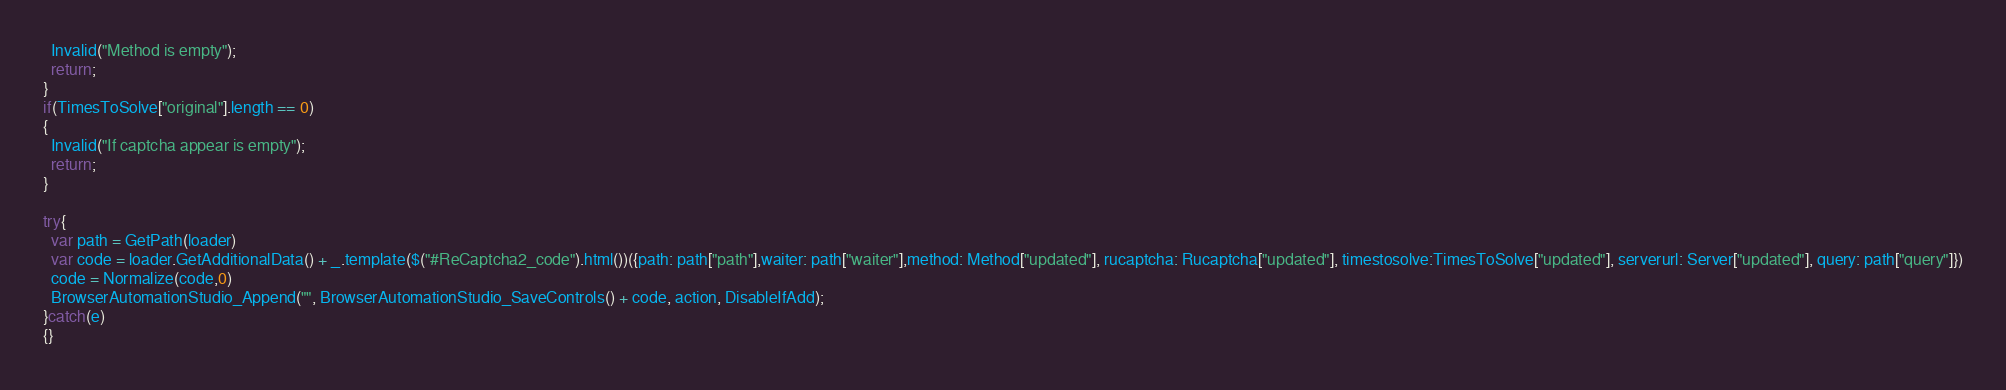<code> <loc_0><loc_0><loc_500><loc_500><_JavaScript_>  Invalid("Method is empty");
  return;
}
if(TimesToSolve["original"].length == 0)
{
  Invalid("If captcha appear is empty");
  return;
}

try{
  var path = GetPath(loader)
  var code = loader.GetAdditionalData() + _.template($("#ReCaptcha2_code").html())({path: path["path"],waiter: path["waiter"],method: Method["updated"], rucaptcha: Rucaptcha["updated"], timestosolve:TimesToSolve["updated"], serverurl: Server["updated"], query: path["query"]})
  code = Normalize(code,0)
  BrowserAutomationStudio_Append("", BrowserAutomationStudio_SaveControls() + code, action, DisableIfAdd);
}catch(e)
{}</code> 